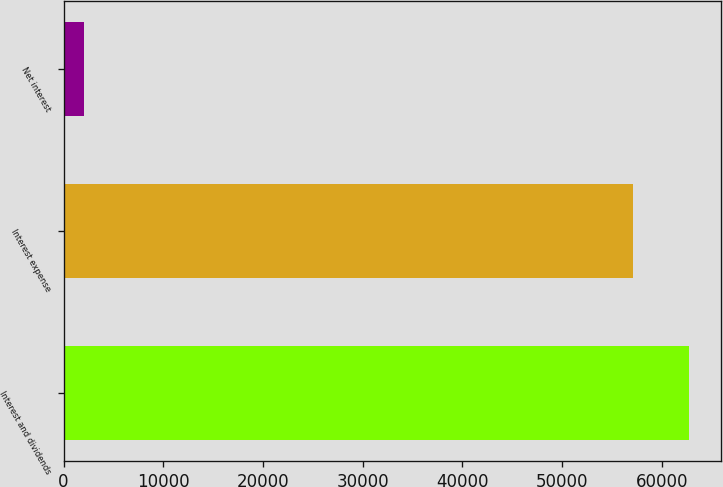Convert chart to OTSL. <chart><loc_0><loc_0><loc_500><loc_500><bar_chart><fcel>Interest and dividends<fcel>Interest expense<fcel>Net interest<nl><fcel>62773.7<fcel>57067<fcel>2064<nl></chart> 